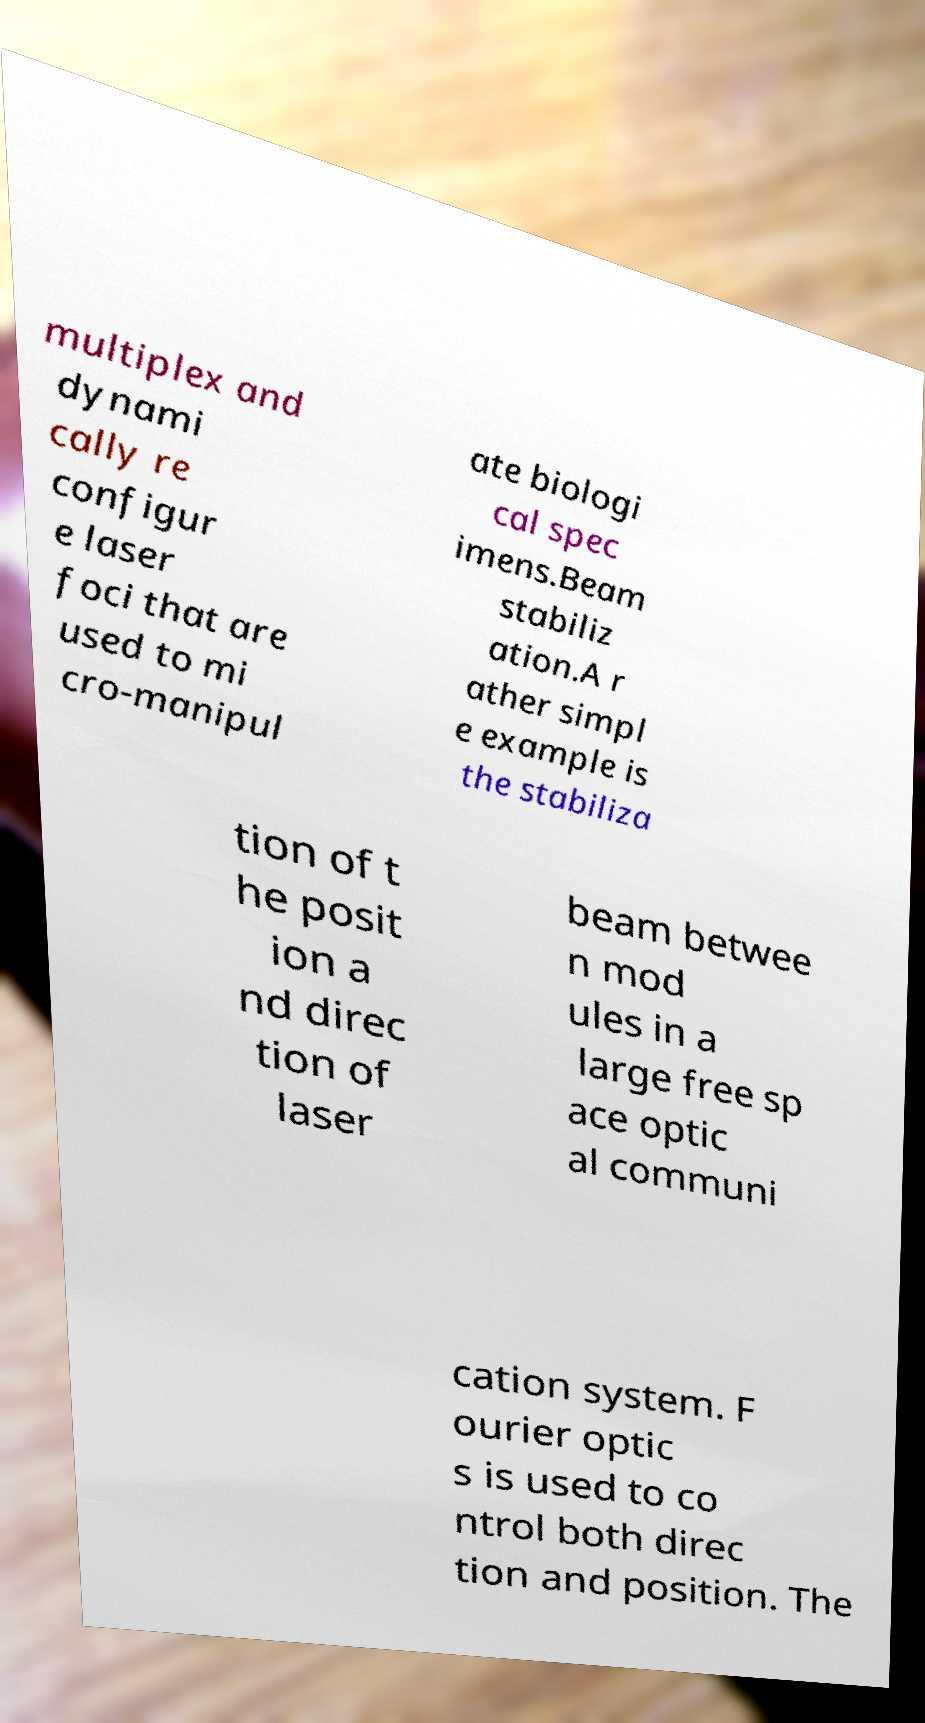Can you read and provide the text displayed in the image?This photo seems to have some interesting text. Can you extract and type it out for me? multiplex and dynami cally re configur e laser foci that are used to mi cro-manipul ate biologi cal spec imens.Beam stabiliz ation.A r ather simpl e example is the stabiliza tion of t he posit ion a nd direc tion of laser beam betwee n mod ules in a large free sp ace optic al communi cation system. F ourier optic s is used to co ntrol both direc tion and position. The 